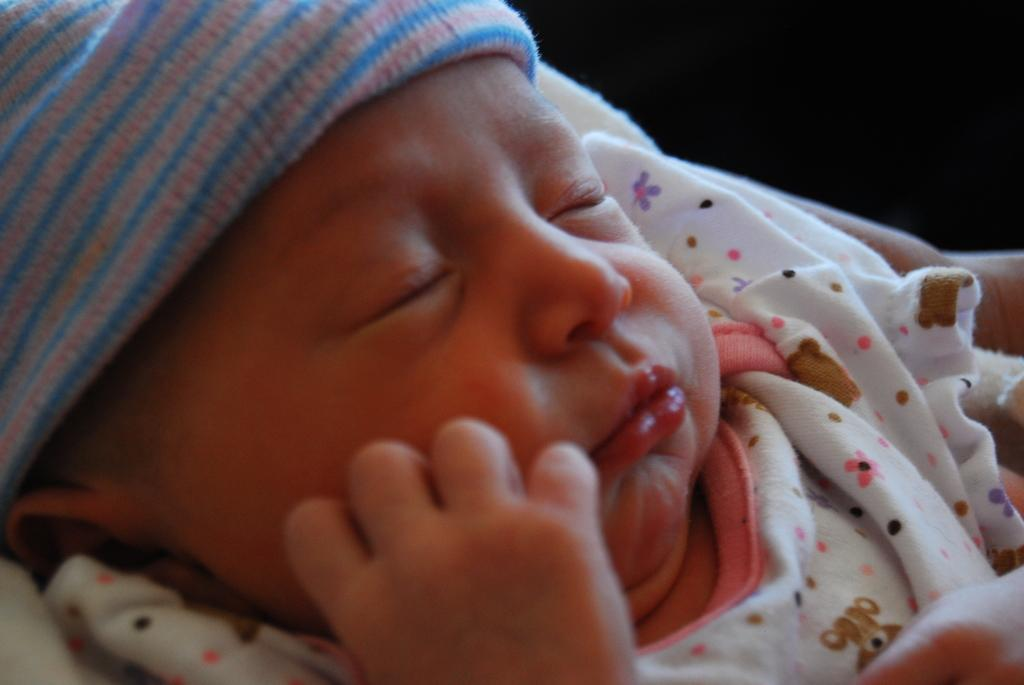What is the main subject of the picture? The main subject of the picture is an infant. What is the infant doing in the image? The infant is sleeping. What is covering the infant in the picture? There is a blanket on the infant. What can be observed about the background of the image? The background of the image is dark. What type of fruit is being used to measure the current in the image? There is no fruit or current present in the image; it features an infant sleeping with a blanket. How much snow can be seen accumulating on the infant in the image? There is no snow present in the image; it is an indoor scene with a sleeping infant. 